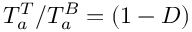Convert formula to latex. <formula><loc_0><loc_0><loc_500><loc_500>T _ { a } ^ { T } / T _ { a } ^ { B } = ( 1 - D )</formula> 